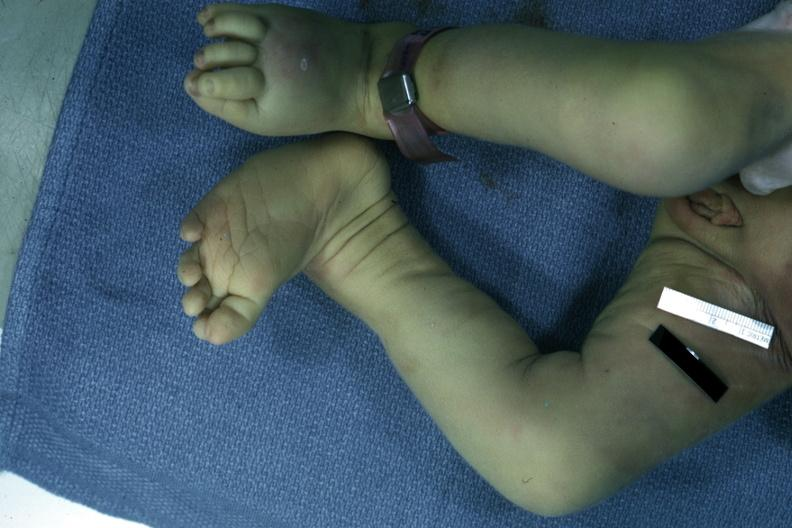what is autopsy left?
Answer the question using a single word or phrase. Club foot 